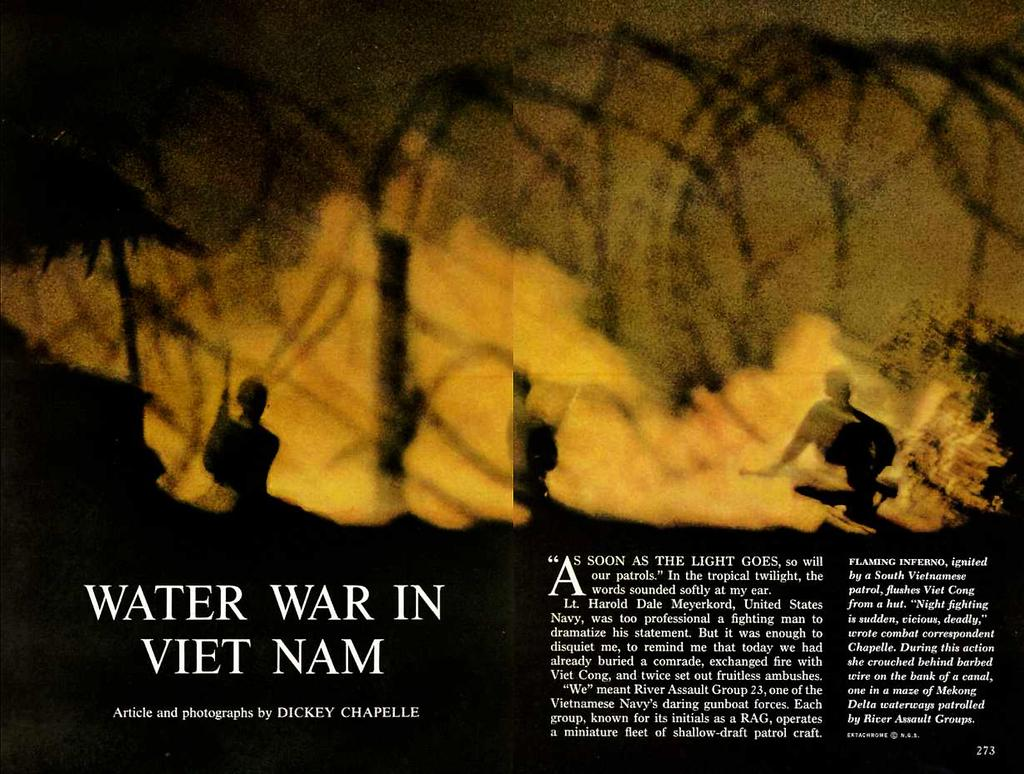Provide a one-sentence caption for the provided image. Water War in Vietnam Article and photographs by Dickey Chapelle. 